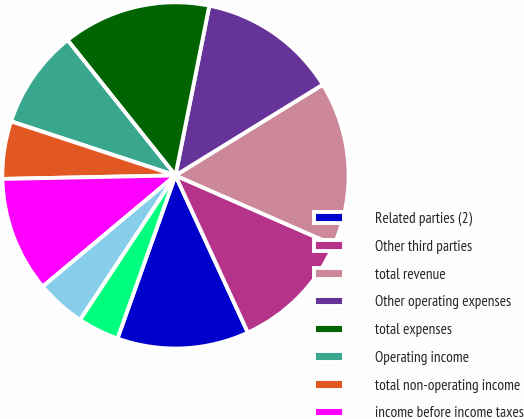<chart> <loc_0><loc_0><loc_500><loc_500><pie_chart><fcel>Related parties (2)<fcel>Other third parties<fcel>total revenue<fcel>Other operating expenses<fcel>total expenses<fcel>Operating income<fcel>total non-operating income<fcel>income before income taxes<fcel>income tax expense<fcel>less net income (loss)<nl><fcel>12.31%<fcel>11.54%<fcel>15.38%<fcel>13.08%<fcel>13.85%<fcel>9.23%<fcel>5.38%<fcel>10.77%<fcel>4.62%<fcel>3.85%<nl></chart> 